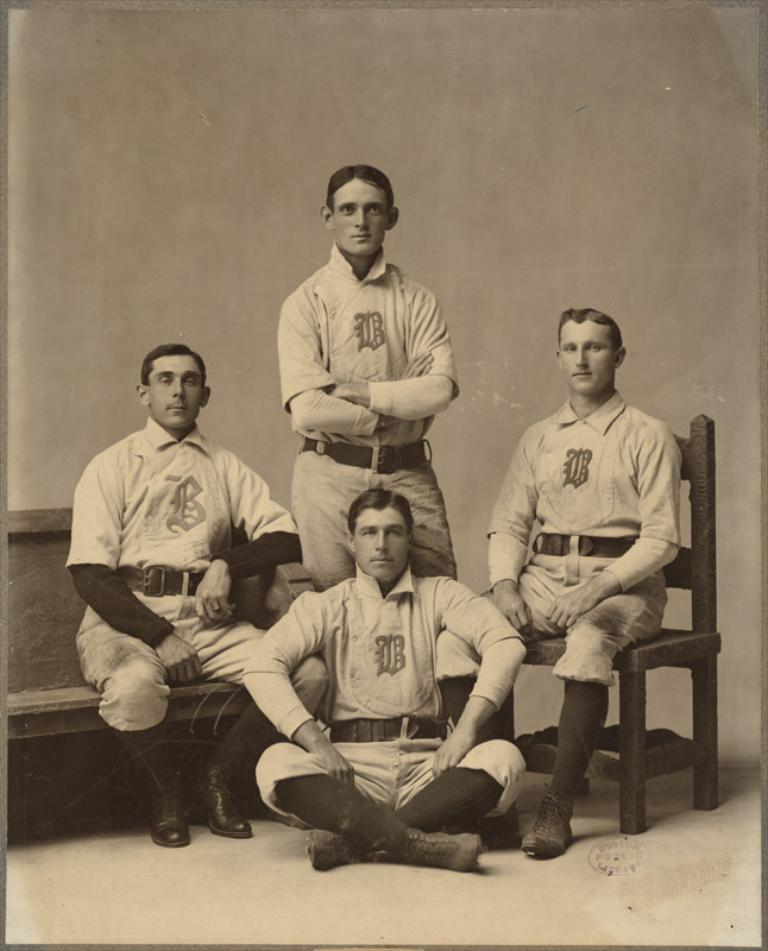How many people are in the image? There are four persons in the image. What are the persons wearing? The persons are wearing white dresses. What is at the bottom of the image? There is a floor at the bottom of the image. What type of furniture can be seen in the image? There is a chair and a bench in the image. What is visible in the background of the image? There is a wall in the background of the image. What type of snails can be seen crawling on the wall in the image? There are no snails present in the image; the wall is a plain background. 